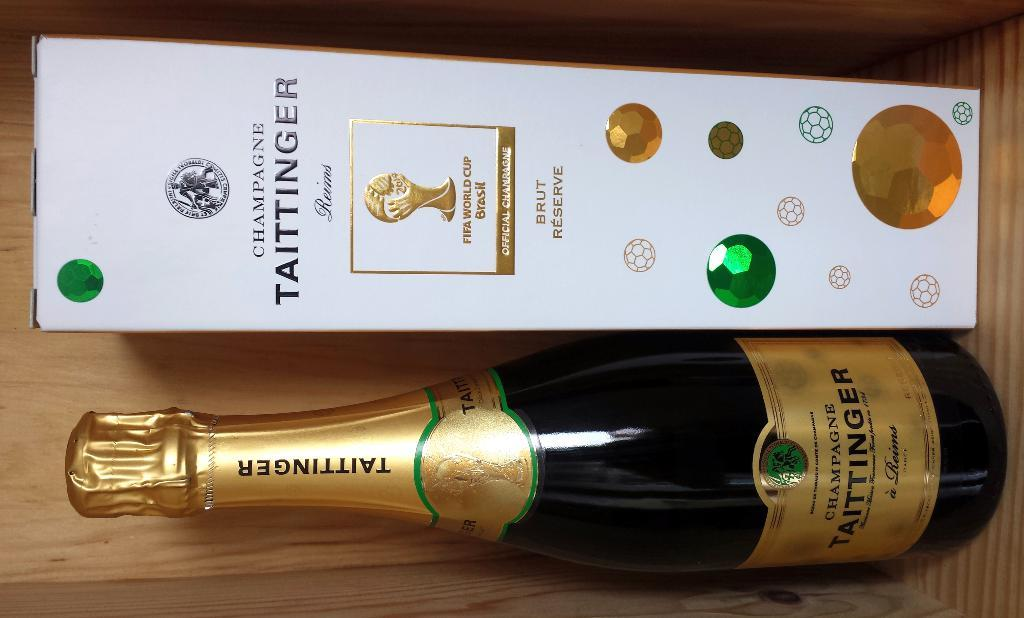<image>
Offer a succinct explanation of the picture presented. A bottle of champagne by TAITTINGER with the box next to the bottle. 